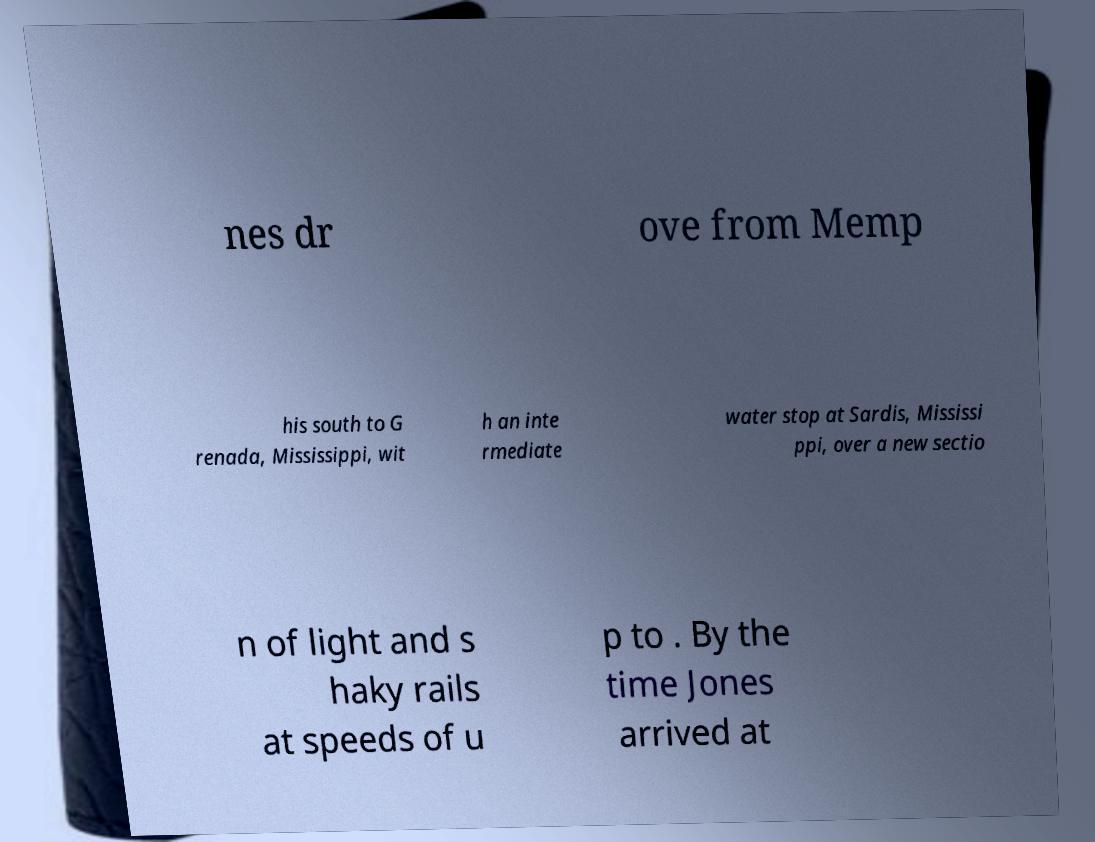Please read and relay the text visible in this image. What does it say? nes dr ove from Memp his south to G renada, Mississippi, wit h an inte rmediate water stop at Sardis, Mississi ppi, over a new sectio n of light and s haky rails at speeds of u p to . By the time Jones arrived at 